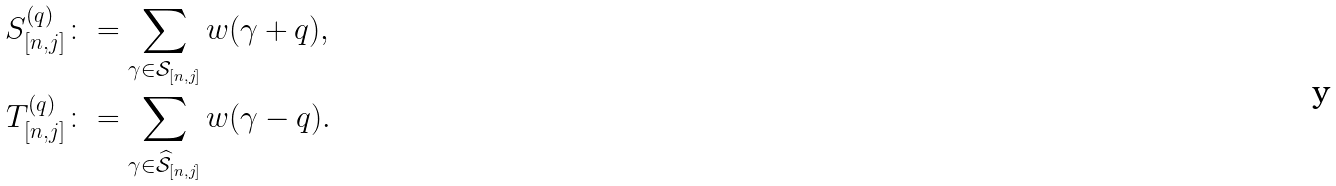<formula> <loc_0><loc_0><loc_500><loc_500>S ^ { ( q ) } _ { [ n , j ] } & \colon = \sum _ { \gamma \in \mathcal { S } _ { [ n , j ] } } w ( \gamma + q ) , \\ T ^ { ( q ) } _ { [ n , j ] } & \colon = \sum _ { \gamma \in \widehat { \mathcal { S } } _ { [ n , j ] } } w ( \gamma - q ) .</formula> 